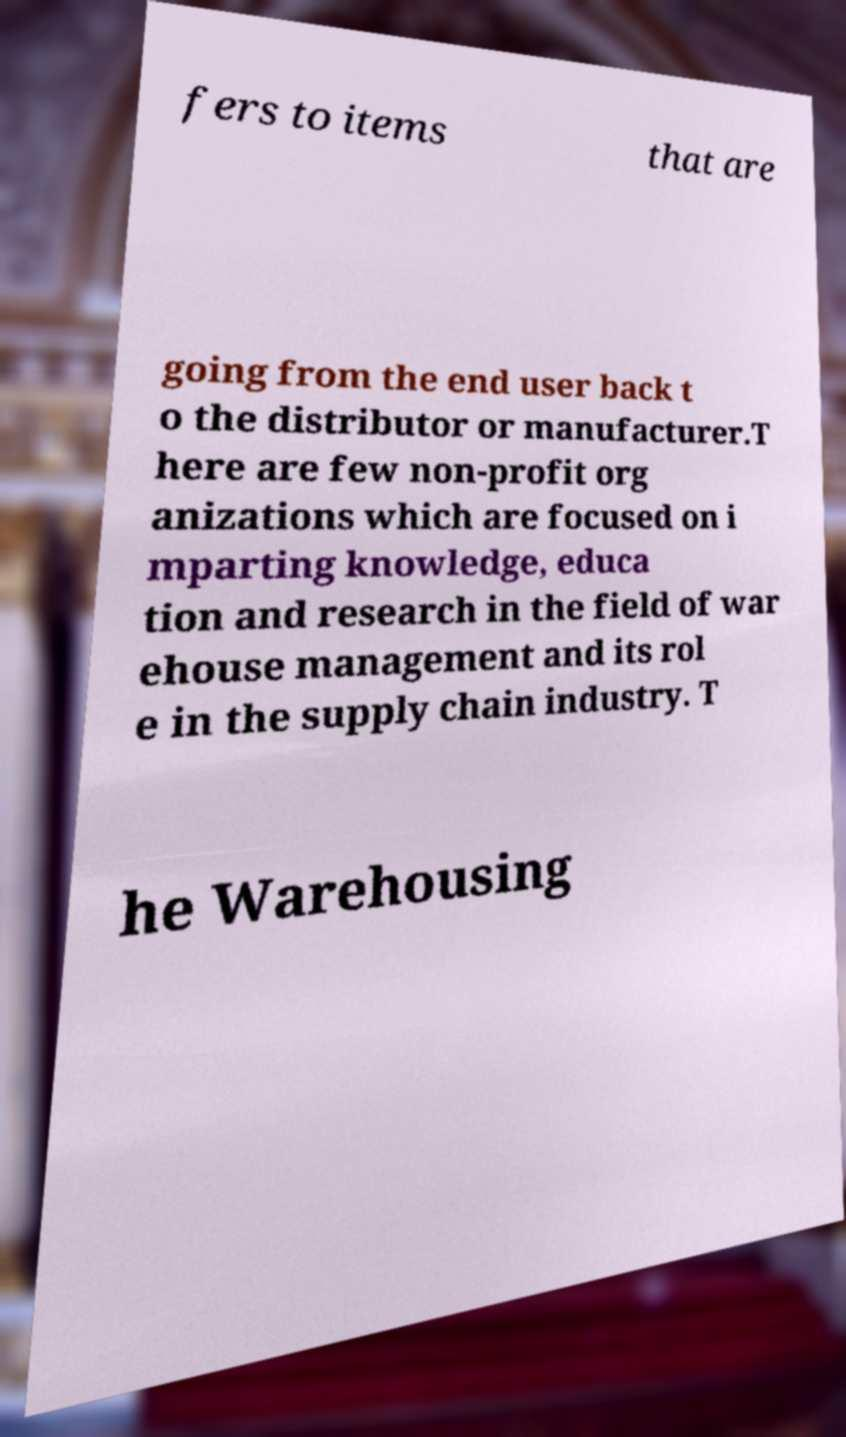Can you accurately transcribe the text from the provided image for me? fers to items that are going from the end user back t o the distributor or manufacturer.T here are few non-profit org anizations which are focused on i mparting knowledge, educa tion and research in the field of war ehouse management and its rol e in the supply chain industry. T he Warehousing 